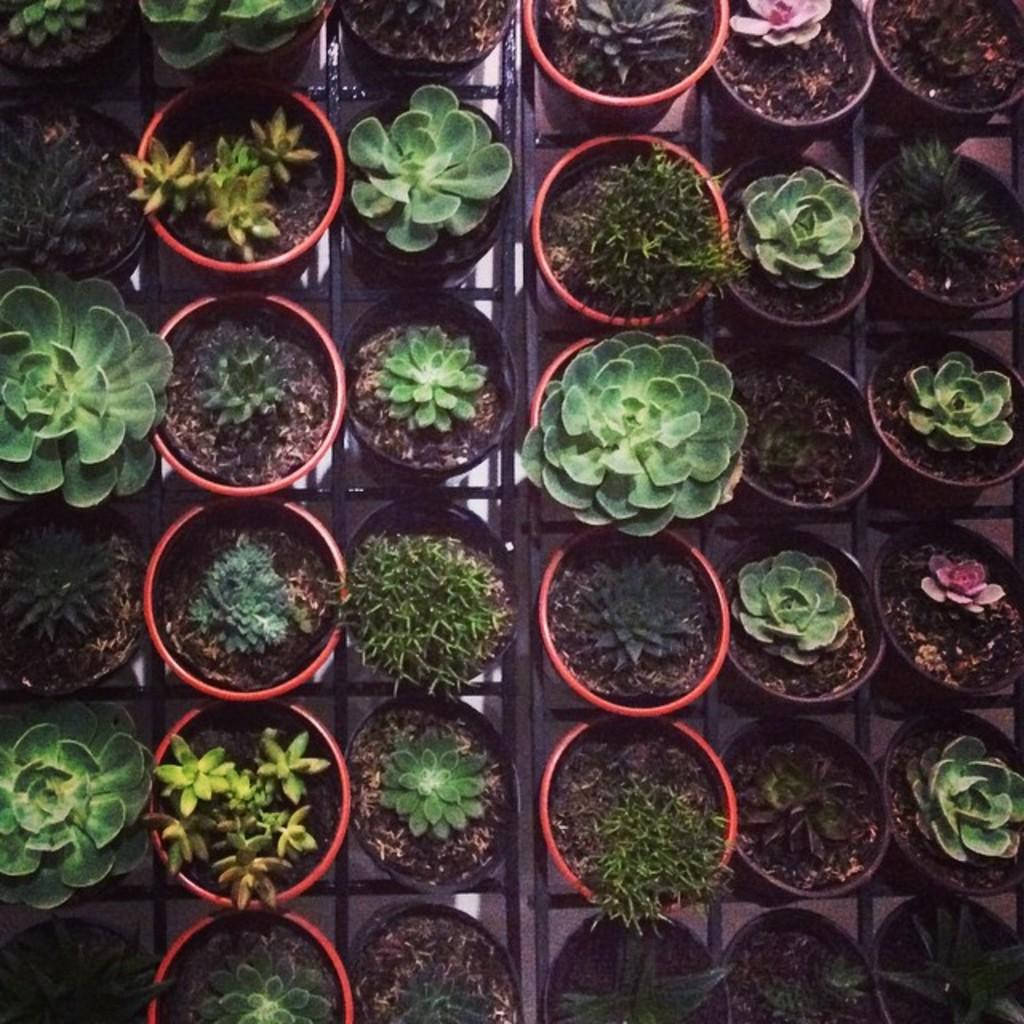What type of plants are in the image? There are potted plants in the image. Where are the potted plants located? The potted plants are on the ground. What type of flesh can be seen on the potted plants in the image? There is no flesh present on the potted plants in the image; they are plants. 